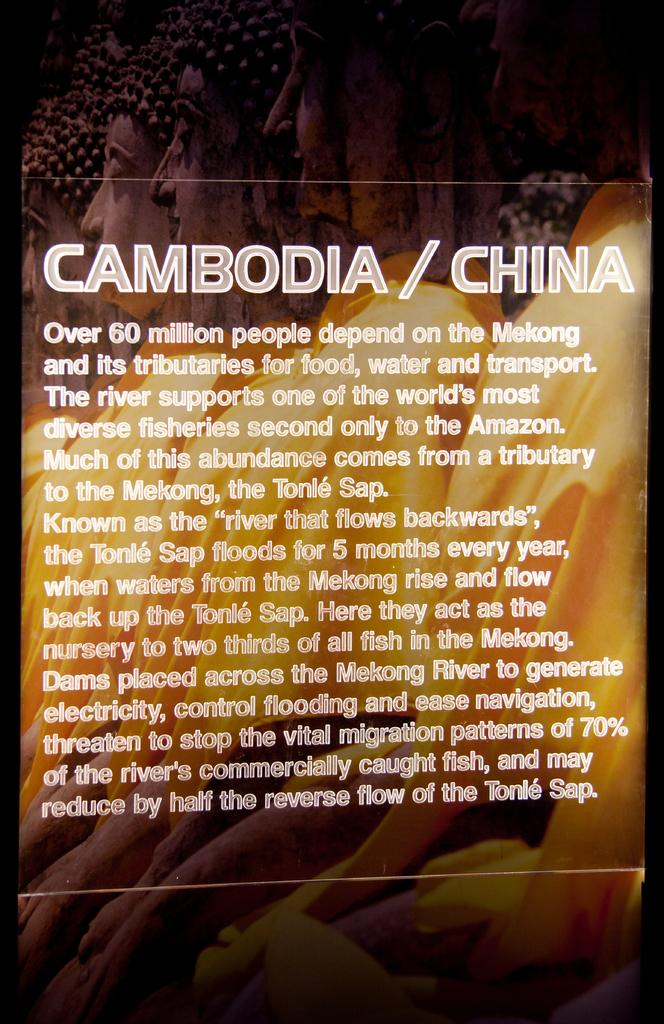<image>
Relay a brief, clear account of the picture shown. A sign gives information about cambodia and china. 